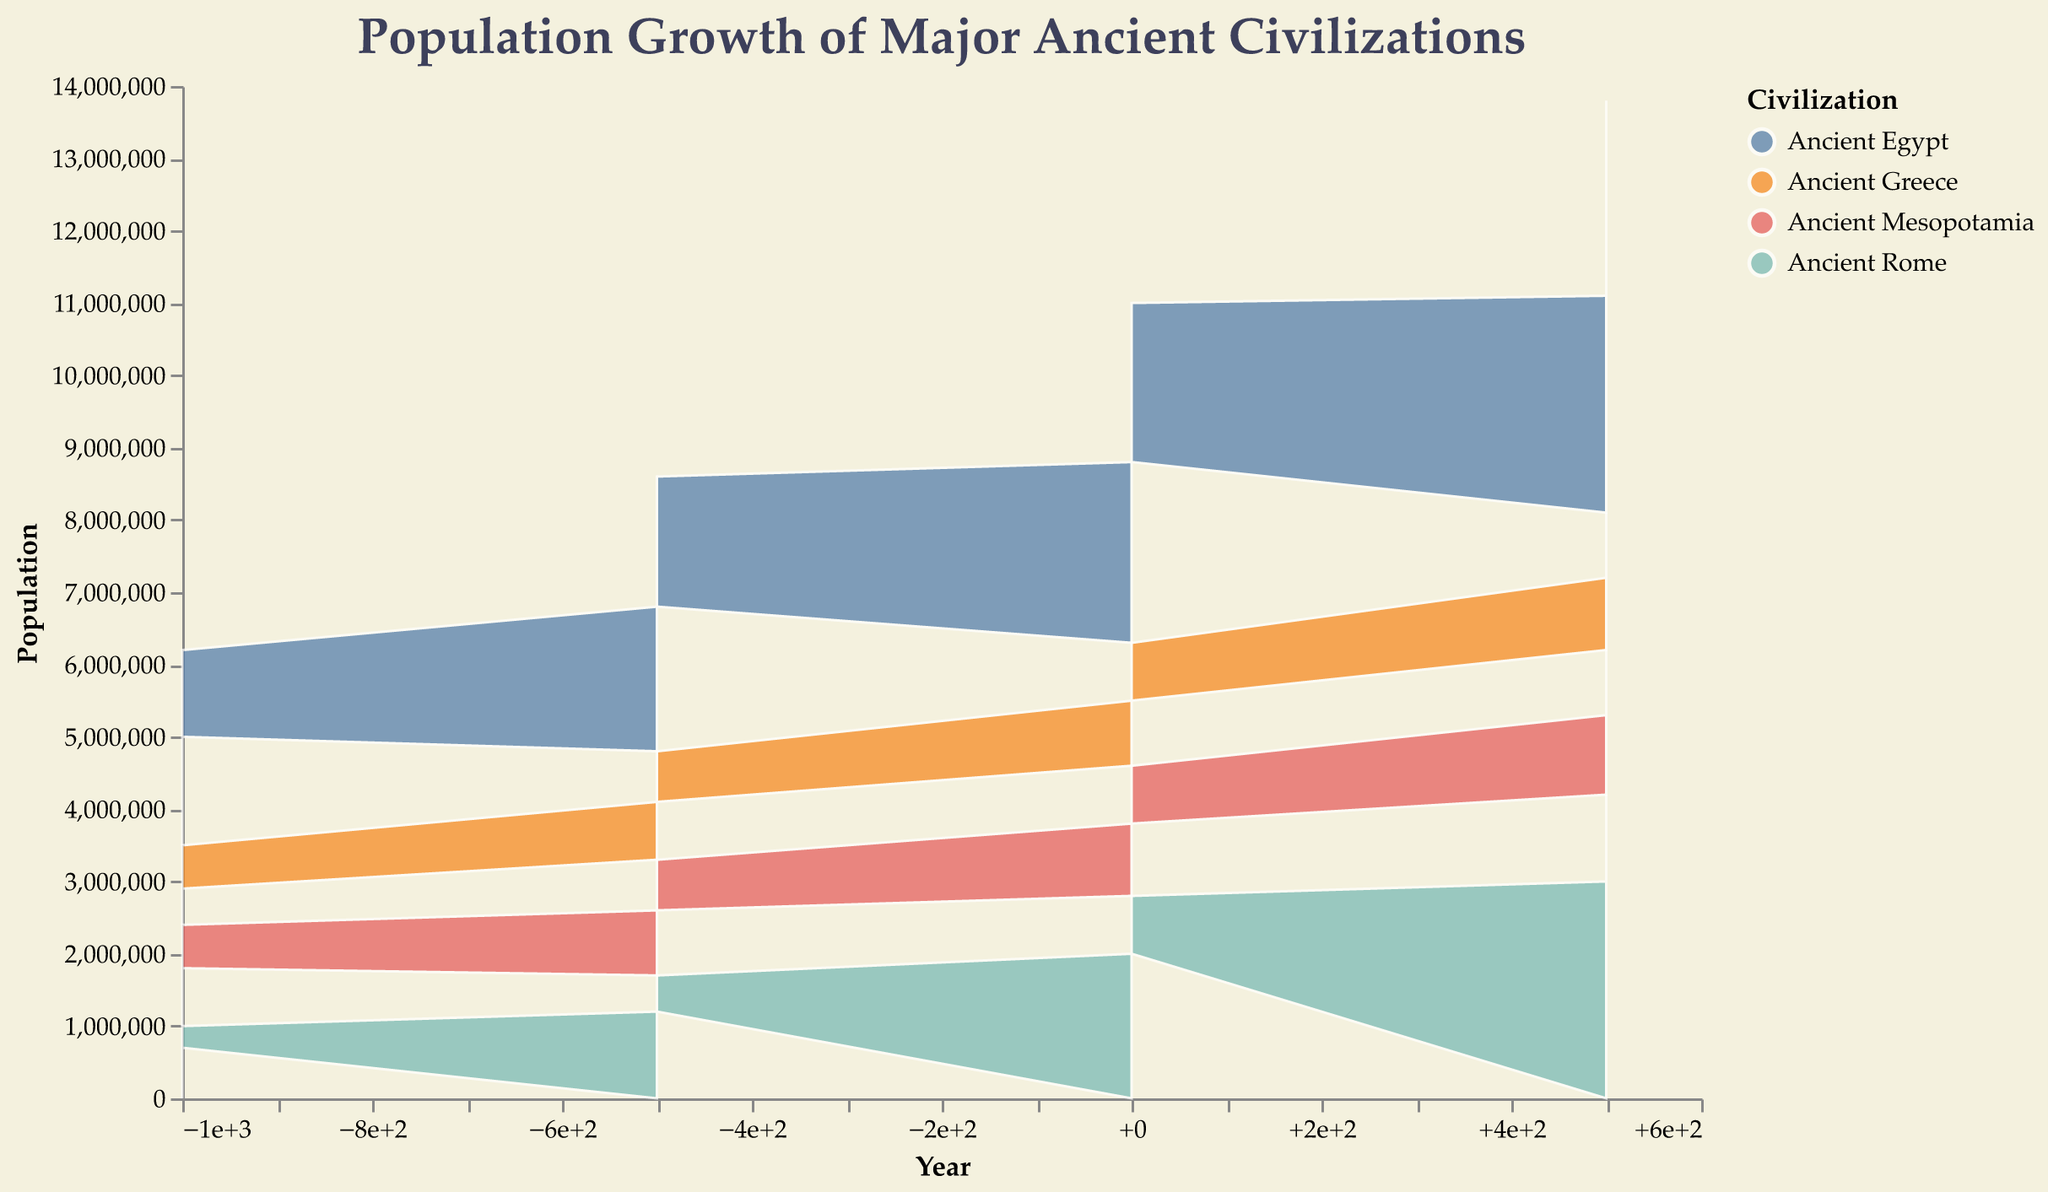What is the title of the figure? The title of a chart is usually located at the top and is the largest text, making it easy to identify the focus of the visualization.
Answer: Population Growth of Major Ancient Civilizations Which civilization has the largest combined population in the year 0? Sum the populations of each region under each civilization for the year 0. For Ancient Egypt: 2,500,000 (Lower Egypt) + 2,200,000 (Upper Egypt) = 4,700,000. For Ancient Mesopotamia: 1,000,000 (Sumer) + 800,000 (Akkad) = 1,800,000. For Ancient Greece: 900,000 (Attica) + 800,000 (Peloponnese) = 1,700,000. For Ancient Rome: 2,000,000 (Italia) + 800,000 (Gallia) = 2,800,000. Ancient Egypt has the largest combined population.
Answer: Ancient Egypt How did the population of Ancient Rome in the Gallia region change from 500 BCE to 500 CE? Locate the population values for Gallia under Ancient Rome for the years -500 and +500. In 500 BCE, the population was 500,000. In 500 CE, the population increased to 1,200,000. Calculate the change: 1,200,000 - 500,000 = 700,000.
Answer: Increased by 700,000 Which civilization experienced the most significant population growth overall from 1000 BCE to 500 CE? Calculate the population change over the entire period for each civilization by summing the populations of each region at 500 CE and subtracting the sums at 1000 BCE. Compare the results to identify the largest increase. Ancient Egypt: (3,000,000 + 2,700,000) - (1,500,000 + 1,200,000) = 2,700,000. Ancient Mesopotamia: (1,100,000 + 900,000) - (800,000 + 600,000) = 600,000. Ancient Greece: (1,000,000 + 900,000) - (500,000 + 600,000) = 800,000. Ancient Rome: (3,000,000 + 1,200,000) - (700,000 + 300,000) = 3,200,000. Ancient Rome had the most significant growth.
Answer: Ancient Rome What is the trend in Ancient Egypt's population in Lower Egypt from 1000 BCE to 500 CE? Identify population values for Lower Egypt under Ancient Egypt for each period. The population starts at 1,500,000 in -1000, increases to 2,000,000 in -500, then to 2,500,000 in 0, and finally to 3,000,000 in +500. Thus, it shows a consistent upward trend.
Answer: Increasing trend Which region in Ancient Greece had a larger population in 500 BCE? Compare the population values for the two regions of Ancient Greece in 500 BCE. Attica's population is 800,000, while Peloponnese's population is 700,000. Attica has a larger population.
Answer: Attica What is the total population in Ancient Mesopotamia for the year 500 CE? Sum the populations of the regions in Ancient Mesopotamia for the year 500 CE. Sumer has a population of 1,100,000, and Akkad has a population of 900,000. The total is 1,100,000 + 900,000 = 2,000,000.
Answer: 2,000,000 